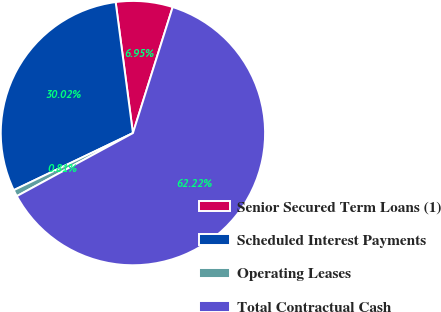Convert chart. <chart><loc_0><loc_0><loc_500><loc_500><pie_chart><fcel>Senior Secured Term Loans (1)<fcel>Scheduled Interest Payments<fcel>Operating Leases<fcel>Total Contractual Cash<nl><fcel>6.95%<fcel>30.02%<fcel>0.81%<fcel>62.22%<nl></chart> 